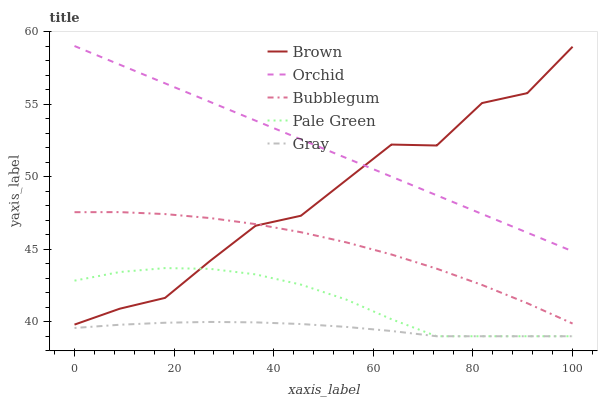Does Gray have the minimum area under the curve?
Answer yes or no. Yes. Does Orchid have the maximum area under the curve?
Answer yes or no. Yes. Does Pale Green have the minimum area under the curve?
Answer yes or no. No. Does Pale Green have the maximum area under the curve?
Answer yes or no. No. Is Orchid the smoothest?
Answer yes or no. Yes. Is Brown the roughest?
Answer yes or no. Yes. Is Gray the smoothest?
Answer yes or no. No. Is Gray the roughest?
Answer yes or no. No. Does Bubblegum have the lowest value?
Answer yes or no. No. Does Orchid have the highest value?
Answer yes or no. Yes. Does Pale Green have the highest value?
Answer yes or no. No. Is Gray less than Brown?
Answer yes or no. Yes. Is Orchid greater than Gray?
Answer yes or no. Yes. Does Brown intersect Orchid?
Answer yes or no. Yes. Is Brown less than Orchid?
Answer yes or no. No. Is Brown greater than Orchid?
Answer yes or no. No. Does Gray intersect Brown?
Answer yes or no. No. 